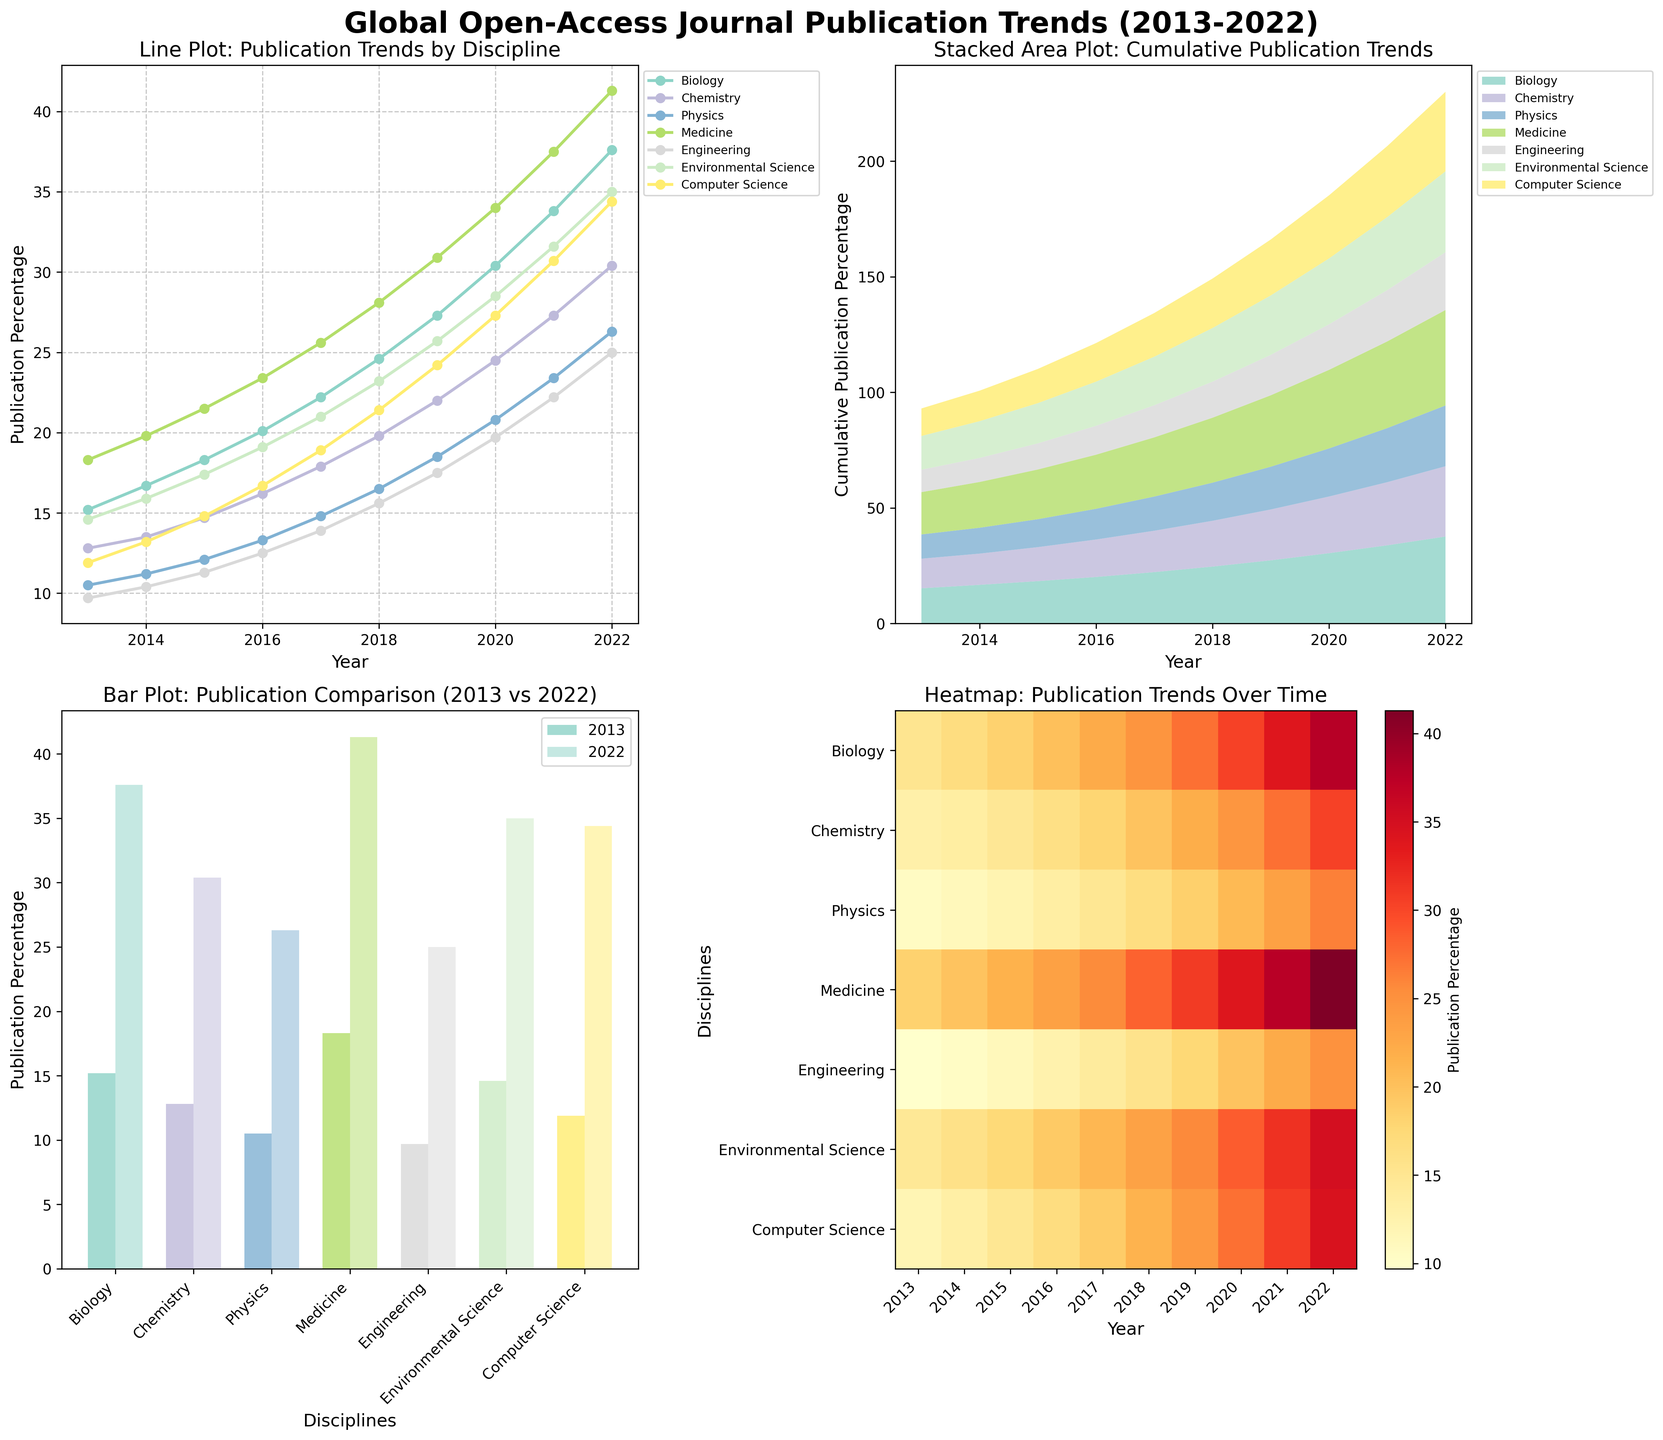What trend can be observed in the publication of open-access journals in the field of Medicine over the past decade? Looking at the line plot and the stacked area plot, Medicine shows an increasing trend in open-access journal publications, rising from 18.3% in 2013 to 41.3% in 2022.
Answer: Increasing trend Which scientific discipline has shown the highest cumulative growth in open-access publications from 2013 to 2022? From the stacked area plot, Medicine shows the highest cumulative growth, as it is the area with the largest increase over the decade.
Answer: Medicine Between which two years did the field of Environmental Science observe the highest increase in publication percentage? Referencing the line plot, the largest increase for Environmental Science occurred between 2015 (17.4%) and 2016 (19.1%), an increase of 1.7%.
Answer: 2015 and 2016 How does the percentage growth in open-access publications in Engineering compare from 2013 to 2022 in the bar plot? Comparing the bars for Engineering in 2013 (9.7%) and 2022 (25.0%), the growth is 15.3%.
Answer: 15.3% What was the percentage of open-access publications in Computer Science in 2020? The line plot shows that Computer Science had a 27.3% open-access publication rate in 2020.
Answer: 27.3% Which discipline had the smallest increase in open-access publication percentage between 2013 and 2014? According to the line plot, Physics had the smallest increase, going from 10.5% in 2013 to 11.2% in 2014, a difference of 0.7%.
Answer: Physics What can be inferred about the relative trends of Biology and Chemistry in open-access publications from 2013 to 2022? From both the line plot and stacked area plot, Biology consistently has a higher publication percentage compared to Chemistry over the decade, and both show an upward trend.
Answer: Biology is higher, both increasing Which year had the highest variance in open-access publications across all disciplines? Observing the heatmap, 2022 shows the highest variance, with notable differences between the lowest and highest percentages across disciplines.
Answer: 2022 How did the cumulative percentage of open-access publications in the field of Physics change from 2013 to 2022? The line plot indicates a gradual increase in Physics from 10.5% in 2013 to 26.3% in 2022.
Answer: Increased Which fields had a publication percentage exceeding 30% by the year 2020? According to the line plot, Biology (30.4%) and Medicine (34.0%) had publication percentages exceeding 30% by 2020.
Answer: Biology and Medicine 